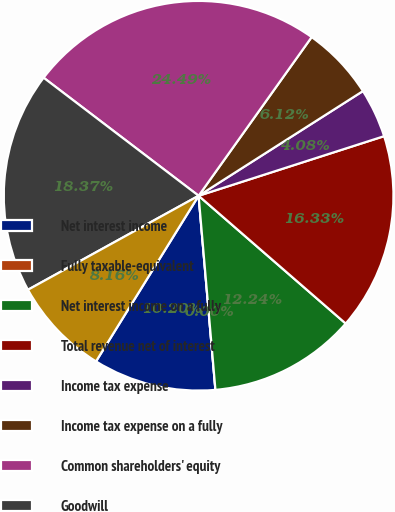Convert chart. <chart><loc_0><loc_0><loc_500><loc_500><pie_chart><fcel>Net interest income<fcel>Fully taxable-equivalent<fcel>Net interest income on a fully<fcel>Total revenue net of interest<fcel>Income tax expense<fcel>Income tax expense on a fully<fcel>Common shareholders' equity<fcel>Goodwill<fcel>Intangible assets (excluding<nl><fcel>10.2%<fcel>0.0%<fcel>12.24%<fcel>16.33%<fcel>4.08%<fcel>6.12%<fcel>24.49%<fcel>18.37%<fcel>8.16%<nl></chart> 